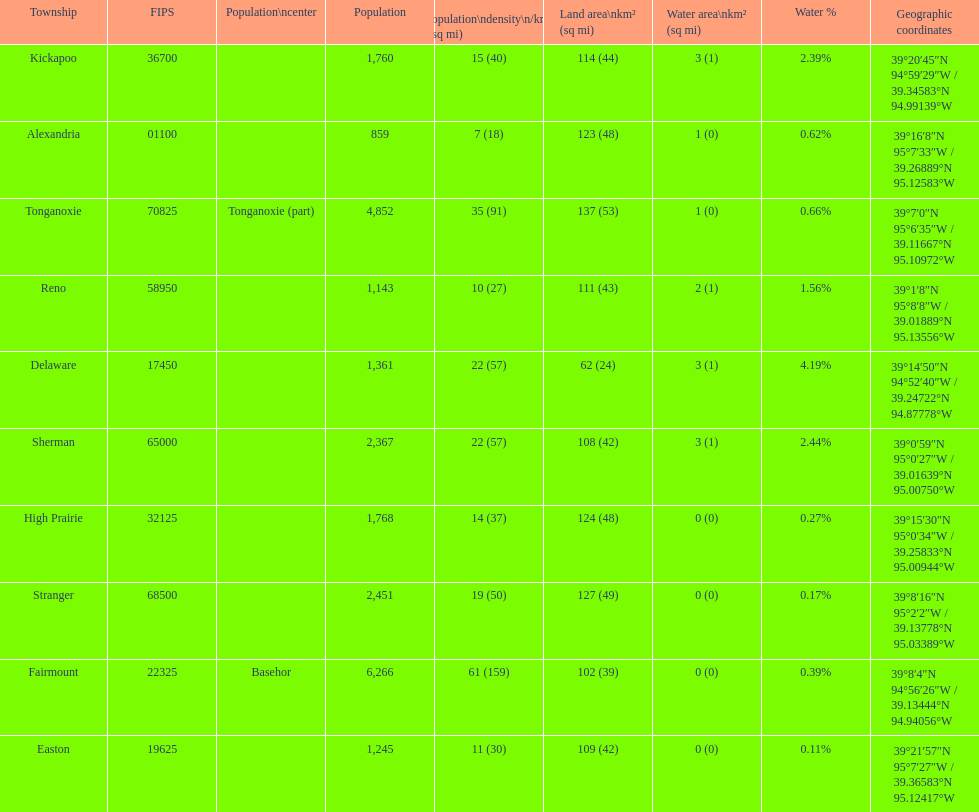What is the difference of population in easton and reno? 102. 